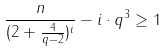Convert formula to latex. <formula><loc_0><loc_0><loc_500><loc_500>\frac { n } { ( 2 + \frac { 4 } { q - 2 } ) ^ { i } } - i \cdot q ^ { 3 } \geq 1</formula> 